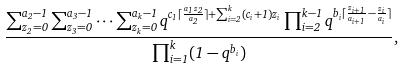Convert formula to latex. <formula><loc_0><loc_0><loc_500><loc_500>\frac { \sum _ { z _ { 2 } = 0 } ^ { a _ { 2 } - 1 } \sum _ { z _ { 3 } = 0 } ^ { a _ { 3 } - 1 } \cdots \sum _ { z _ { k } = 0 } ^ { a _ { k } - 1 } q ^ { c _ { 1 } \lceil \frac { a _ { 1 } z _ { 2 } } { a _ { 2 } } \rceil + \sum _ { i = 2 } ^ { k } ( c _ { i } + 1 ) z _ { i } } \prod _ { i = 2 } ^ { k - 1 } q ^ { b _ { i } \lceil \frac { z _ { i + 1 } } { a _ { i + 1 } } - \frac { z _ { i } } { a _ { i } } \rceil } } { \prod _ { i = 1 } ^ { k } ( 1 - q ^ { b _ { i } } ) } ,</formula> 